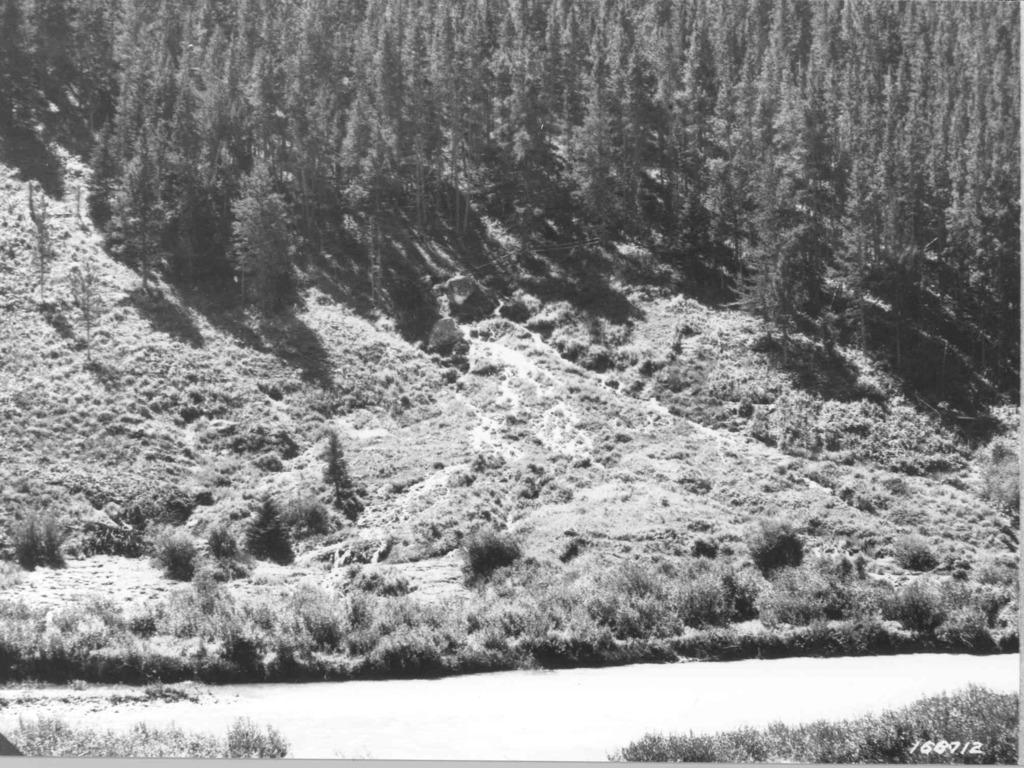What is the color scheme of the image? The image is in black and white. What geographical feature is present in the image? There is a hill in the image. What type of vegetation can be seen on the hill? The hill has grass, plants, and trees. What type of vegetation is present at the bottom of the hill? There are plants on the land at the bottom of the image. What is the price of the comb in the image? There is no comb present in the image, so it is not possible to determine its price. 